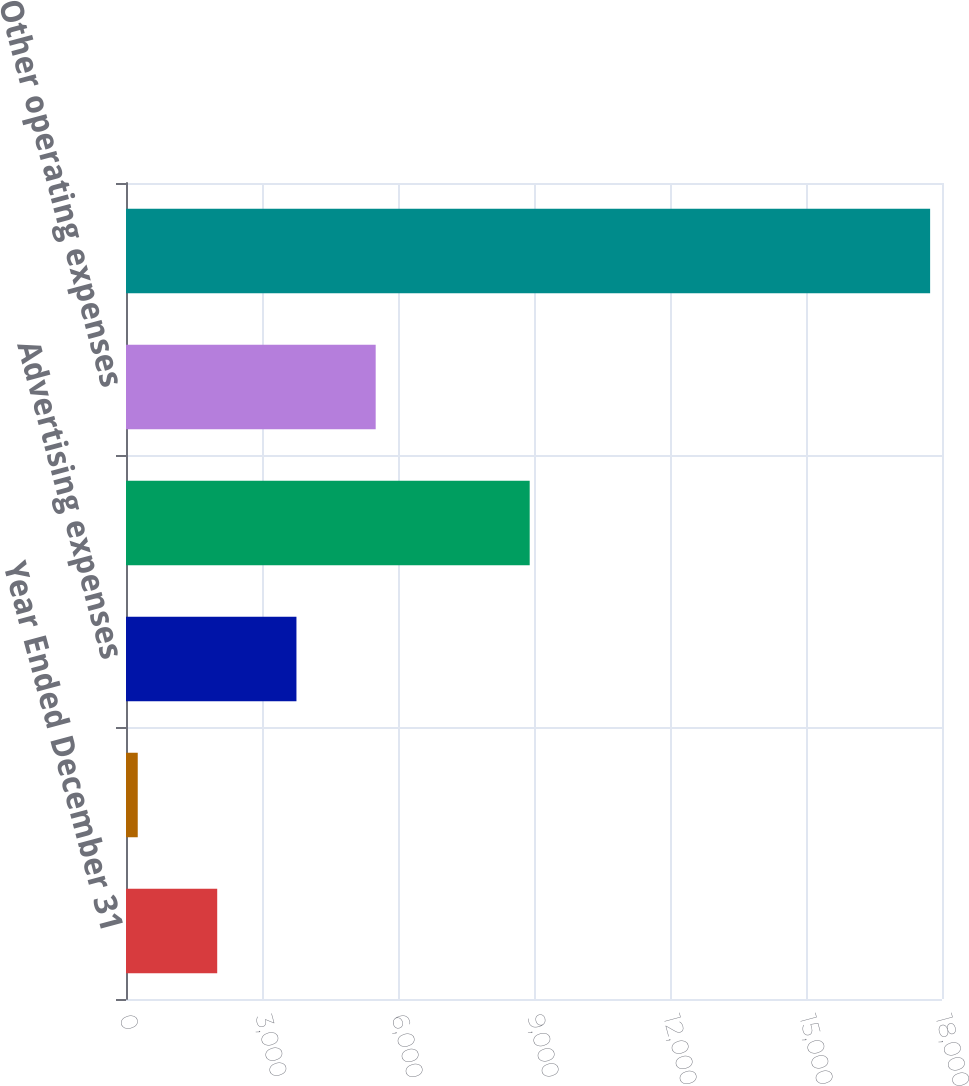<chart> <loc_0><loc_0><loc_500><loc_500><bar_chart><fcel>Year Ended December 31<fcel>Stock-based compensation<fcel>Advertising expenses<fcel>Bottling and distribution<fcel>Other operating expenses<fcel>Selling general and<nl><fcel>2012<fcel>259<fcel>3759.9<fcel>8905<fcel>5507.8<fcel>17738<nl></chart> 